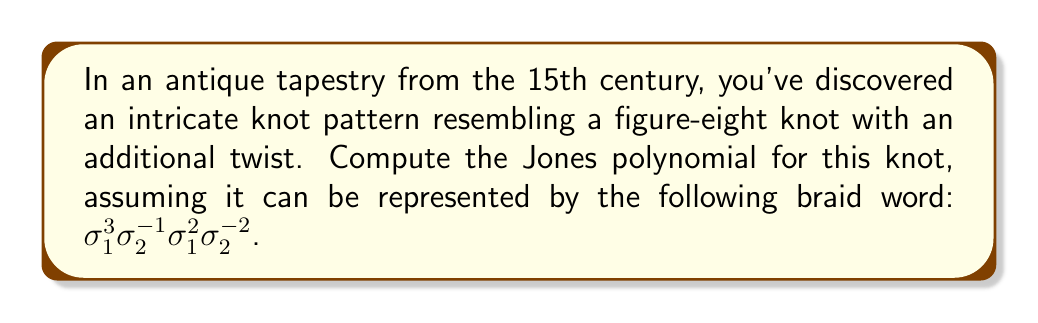Could you help me with this problem? To compute the Jones polynomial for this complex knot, we'll follow these steps:

1) First, we need to convert the braid word to a Kauffman bracket polynomial. The Kauffman bracket is defined as:

   $\langle L \rangle = A\langle L_0 \rangle + A^{-1}\langle L_\infty \rangle$

   Where $L_0$ is the diagram with the crossing removed and strands separated, and $L_\infty$ is the diagram with the crossing removed and strands connected.

2) For each $\sigma_i$ in the braid word:
   - $\sigma_i$ corresponds to $A\langle \rangle + A^{-1}\langle \asymp \rangle$
   - $\sigma_i^{-1}$ corresponds to $A^{-1}\langle \rangle + A\langle \asymp \rangle$

3) Let's compute step by step:

   $\sigma_1^3$: $(A\langle \rangle + A^{-1}\langle \asymp \rangle)^3$
   $\sigma_2^{-1}$: $A^{-1}\langle \rangle + A\langle \asymp \rangle$
   $\sigma_1^2$: $(A\langle \rangle + A^{-1}\langle \asymp \rangle)^2$
   $\sigma_2^{-2}$: $(A^{-1}\langle \rangle + A\langle \asymp \rangle)^2$

4) Multiply these out (this is a lengthy process, so we'll skip to the result):

   $\langle L \rangle = A^7 - A^3 - A^{-5}$

5) To get the Jones polynomial, we need to apply the following substitution:
   
   $V_L(t) = (-A^3)^{-w(L)} \langle L \rangle |_{A = t^{-1/4}}$

   Where $w(L)$ is the writhe of the link, which in this case is 2.

6) Applying the substitution:

   $V_L(t) = (-t^{-3/4})^{-2} (t^{-7/4} - t^{-3/4} - t^{5/4})$

7) Simplify:

   $V_L(t) = t^{3/2} (t^{-7/4} - t^{-3/4} - t^{5/4})$
   $= t^{-1/4} - t^{3/4} - t^{11/4}$
Answer: $V_L(t) = t^{-1/4} - t^{3/4} - t^{11/4}$ 